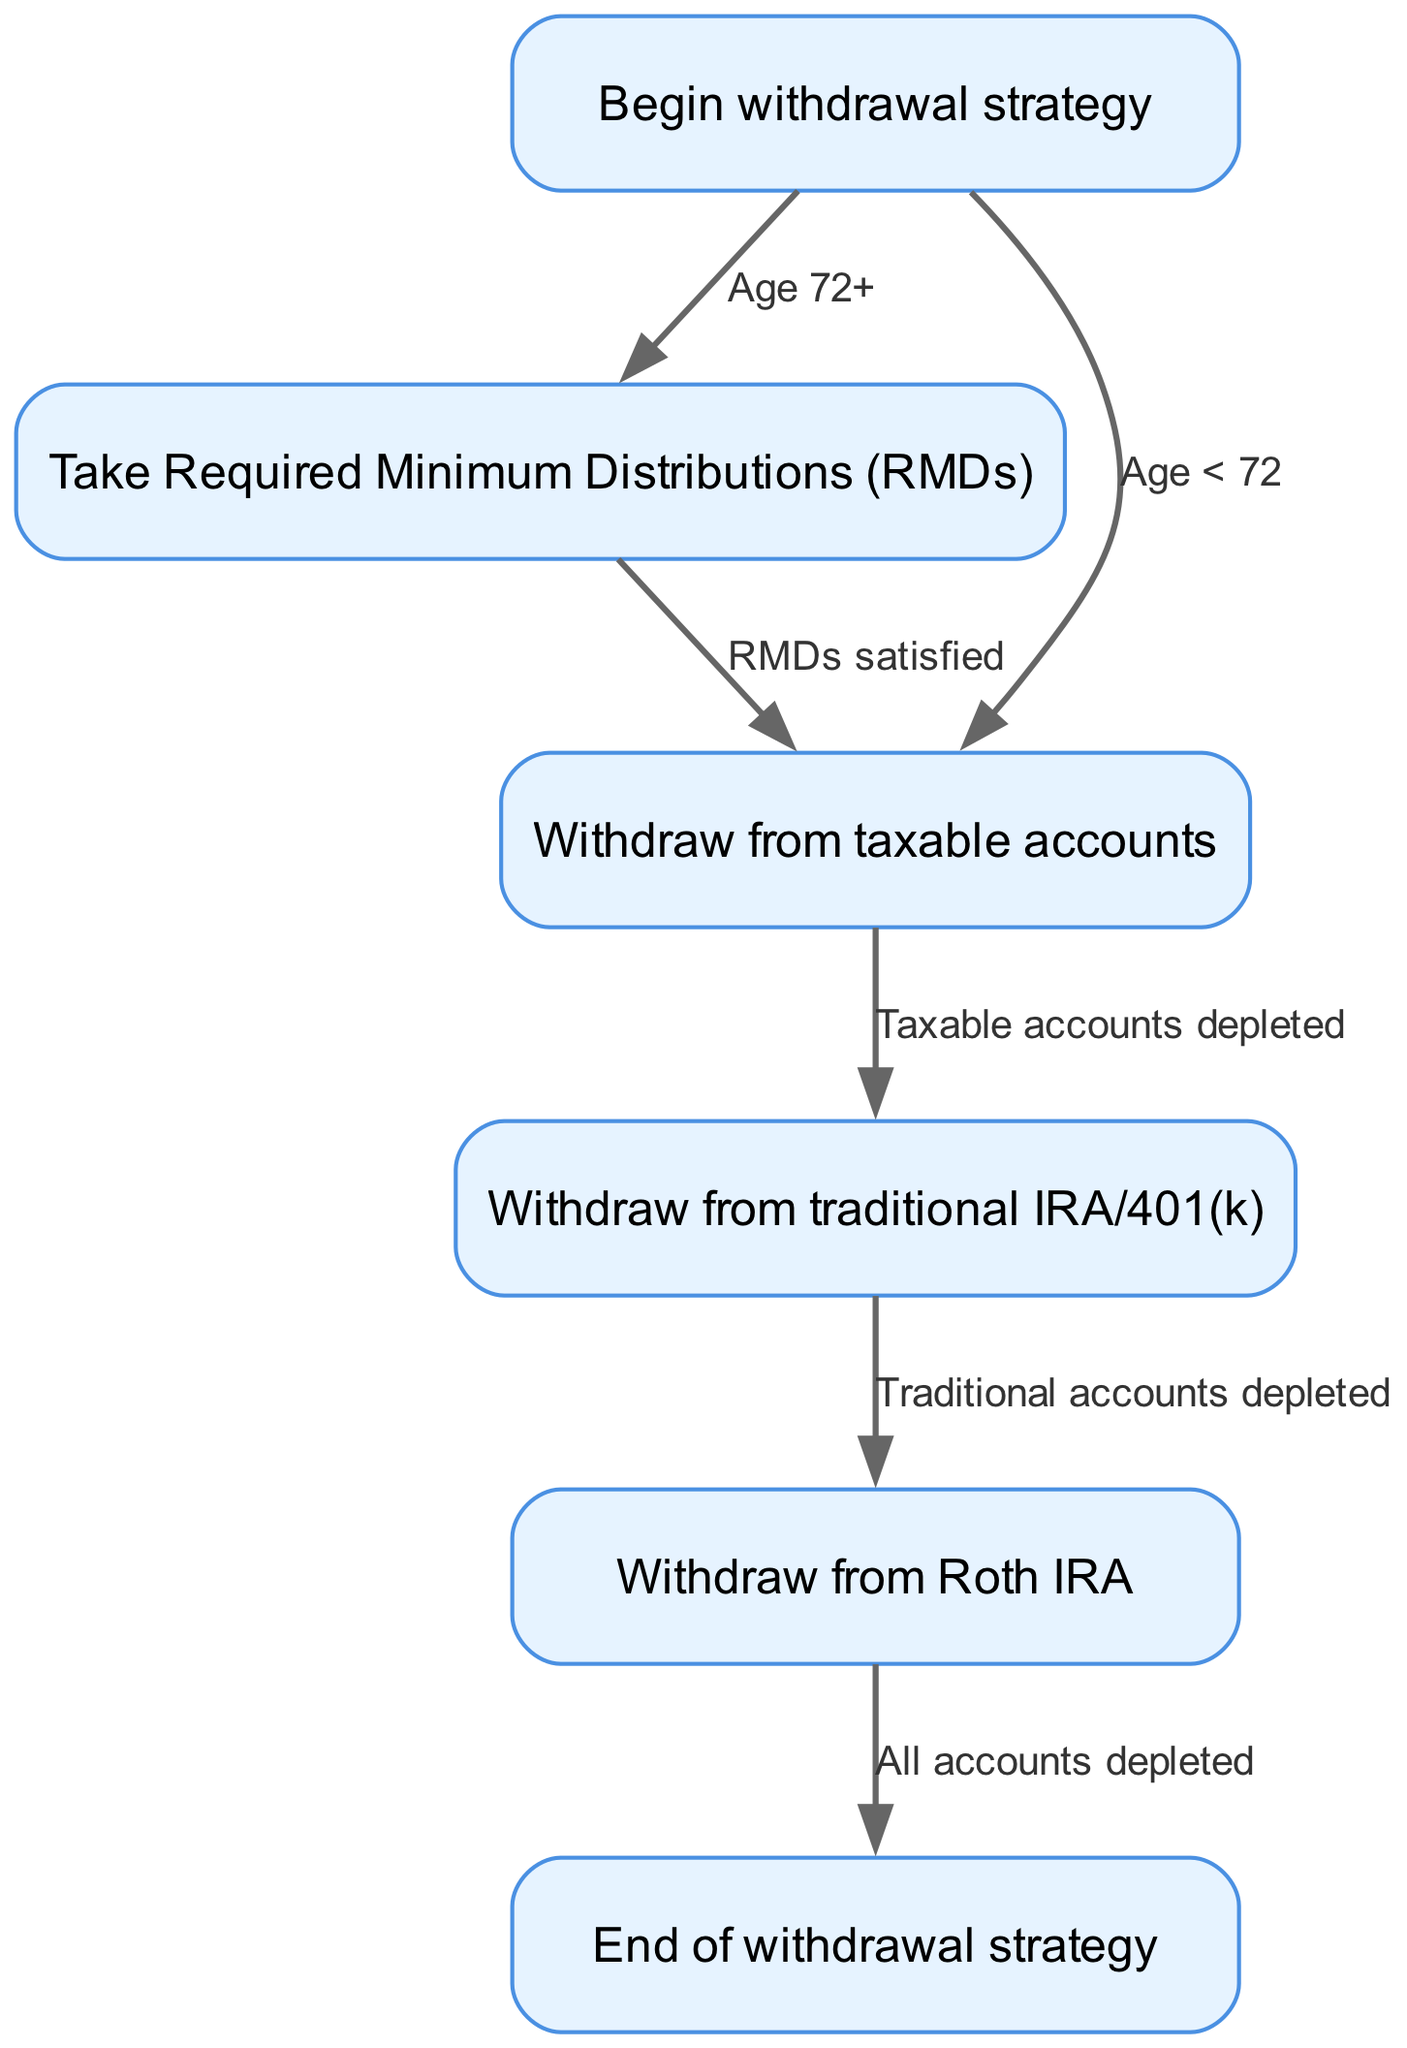What is the starting point of the withdrawal strategy? The diagram indicates that the process begins at the node labeled "Begin withdrawal strategy." This is the entry point of the flowchart, marking where the withdrawal plan commences.
Answer: Begin withdrawal strategy How many nodes are present in the diagram? The diagram contains six nodes: "Begin withdrawal strategy," "Take Required Minimum Distributions (RMDs)," "Withdraw from taxable accounts," "Withdraw from traditional IRA/401(k)," "Withdraw from Roth IRA," and "End of withdrawal strategy." Counting these gives a total of six nodes.
Answer: Six What action is taken if the individual is aged 72 or older? According to the flowchart, if an individual is aged 72 or older, they will take Required Minimum Distributions (RMDs). This is the action specified for this age group as indicated by the edge connecting "Begin withdrawal strategy" to "Take Required Minimum Distributions (RMDs)."
Answer: Take Required Minimum Distributions What happens after satisfying RMDs? Following the satisfaction of RMDs, the next step is to withdraw from taxable accounts. This flow is depicted by the edge that leads from "Take Required Minimum Distributions (RMDs)" to "Withdraw from taxable accounts."
Answer: Withdraw from taxable accounts What is the final action in the withdrawal process? The last action described in the flowchart is to reach the end of the withdrawal strategy, indicated by the node "End of withdrawal strategy." It signifies the conclusion of the withdrawal sequence for all accounts.
Answer: End of withdrawal strategy If taxable accounts are depleted, which accounts are withdrawn from next? The diagram specifies that if taxable accounts are depleted, the next step is to withdraw from traditional IRA/401(k). The edge connects "Withdraw from taxable accounts" to "Withdraw from traditional IRA/401(k)," indicating this sequential action.
Answer: Withdraw from traditional IRA/401(k) What is the sequence of account withdrawals after reaching age 72? After reaching age 72, the sequence involves first taking RMDs, then withdrawing from taxable accounts. Once taxable accounts are depleted, the process continues with withdrawals from traditional IRA/401(k), and finally Roth IRA, before ending the strategy. The sequence of nodes visited would be RMDs, taxable, traditional, Roth, and then end.
Answer: RMDs, taxable, traditional, Roth What is the condition to withdraw from Roth IRA? The condition to withdraw from Roth IRA is that traditional accounts must be completely depleted first. This is shown in the flowchart where an edge leads from "Withdraw from traditional IRA/401(k)" to "Withdraw from Roth IRA."
Answer: Traditional accounts depleted 